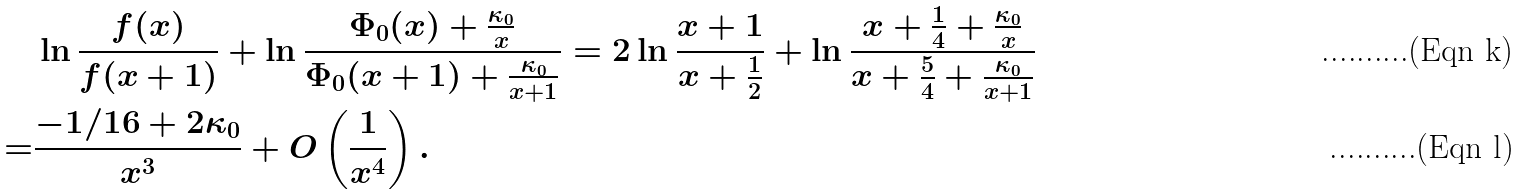<formula> <loc_0><loc_0><loc_500><loc_500>& \ln \frac { f ( x ) } { f ( x + 1 ) } + \ln \frac { \Phi _ { 0 } ( x ) + \frac { \kappa _ { 0 } } { x } } { \Phi _ { 0 } ( x + 1 ) + \frac { \kappa _ { 0 } } { x + 1 } } = 2 \ln \frac { x + 1 } { x + \frac { 1 } { 2 } } + \ln \frac { x + \frac { 1 } { 4 } + \frac { \kappa _ { 0 } } { x } } { x + \frac { 5 } { 4 } + \frac { \kappa _ { 0 } } { x + 1 } } \\ = & \frac { - 1 / 1 6 + 2 \kappa _ { 0 } } { x ^ { 3 } } + O \left ( \frac { 1 } { x ^ { 4 } } \right ) .</formula> 